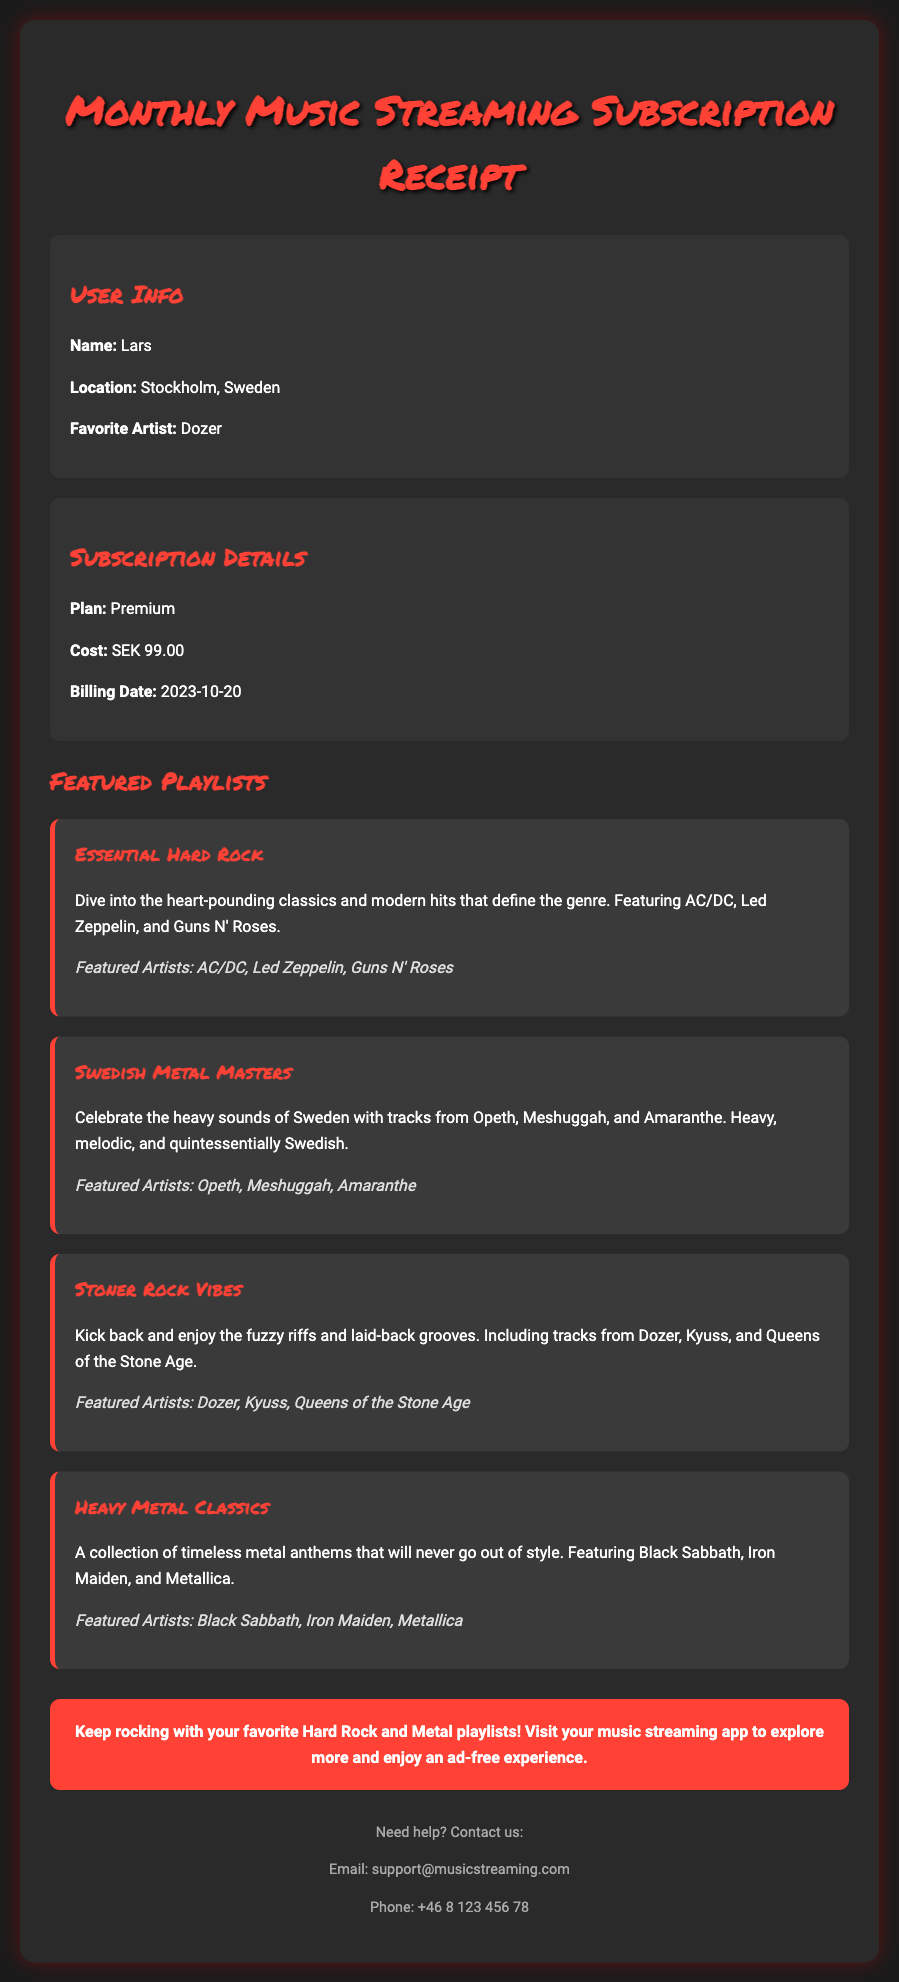What is the user's favorite artist? The user's favorite artist is mentioned in the user info section of the document.
Answer: Dozer What is the subscription cost? The subscription cost is explicitly stated in the subscription details section.
Answer: SEK 99.00 When is the billing date? The billing date is provided in the subscription details section of the document.
Answer: 2023-10-20 Which playlist features Dozer? The playlist that specifically mentions Dozer is listed in the featured playlists section.
Answer: Stoner Rock Vibes What type of plan does the user have? The type of plan is detailed in the subscription details section.
Answer: Premium Name one artist from the "Swedish Metal Masters" playlist. At least one artist from the playlist is listed in the document.
Answer: Opeth How many featured playlists are there? The number of featured playlists can be counted from the document.
Answer: Four What color is the background of the container? The document describes the background color of the container.
Answer: #2a2a2a What is the support email address? The support email address is provided at the end of the document.
Answer: support@musicstreaming.com 